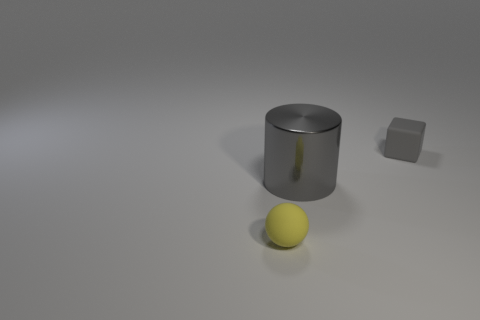Do the tiny thing that is behind the tiny ball and the object in front of the big metal thing have the same shape?
Offer a terse response. No. There is a object that is the same size as the cube; what is its material?
Your answer should be compact. Rubber. What number of other things are there of the same material as the big gray thing
Offer a terse response. 0. The rubber object right of the rubber object that is in front of the big cylinder is what shape?
Give a very brief answer. Cube. How many objects are big metal cylinders or large gray cylinders that are on the right side of the tiny sphere?
Make the answer very short. 1. How many other things are the same color as the big shiny cylinder?
Give a very brief answer. 1. How many green things are small blocks or shiny objects?
Your answer should be very brief. 0. Is there a small yellow rubber object left of the tiny matte object in front of the object that is behind the gray cylinder?
Offer a terse response. No. Is there any other thing that is the same size as the yellow ball?
Make the answer very short. Yes. Is the color of the big metallic cylinder the same as the small block?
Your answer should be compact. Yes. 